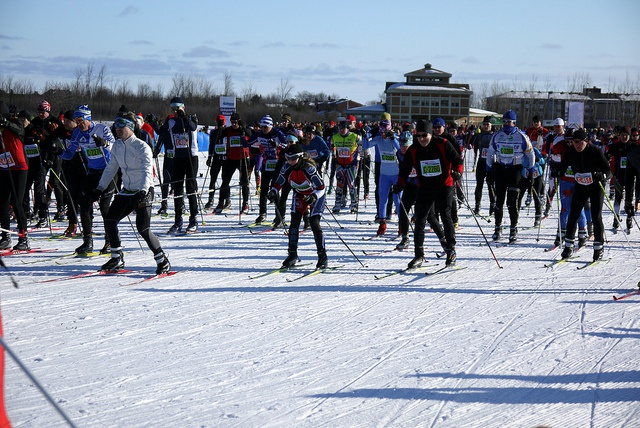Describe the objects in this image and their specific colors. I can see people in darkgray, black, lightgray, and gray tones, people in darkgray, black, gray, and lightgray tones, people in darkgray, black, gray, and maroon tones, people in darkgray, black, gray, and navy tones, and people in darkgray, black, navy, and gray tones in this image. 